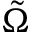Convert formula to latex. <formula><loc_0><loc_0><loc_500><loc_500>\tilde { \Omega }</formula> 